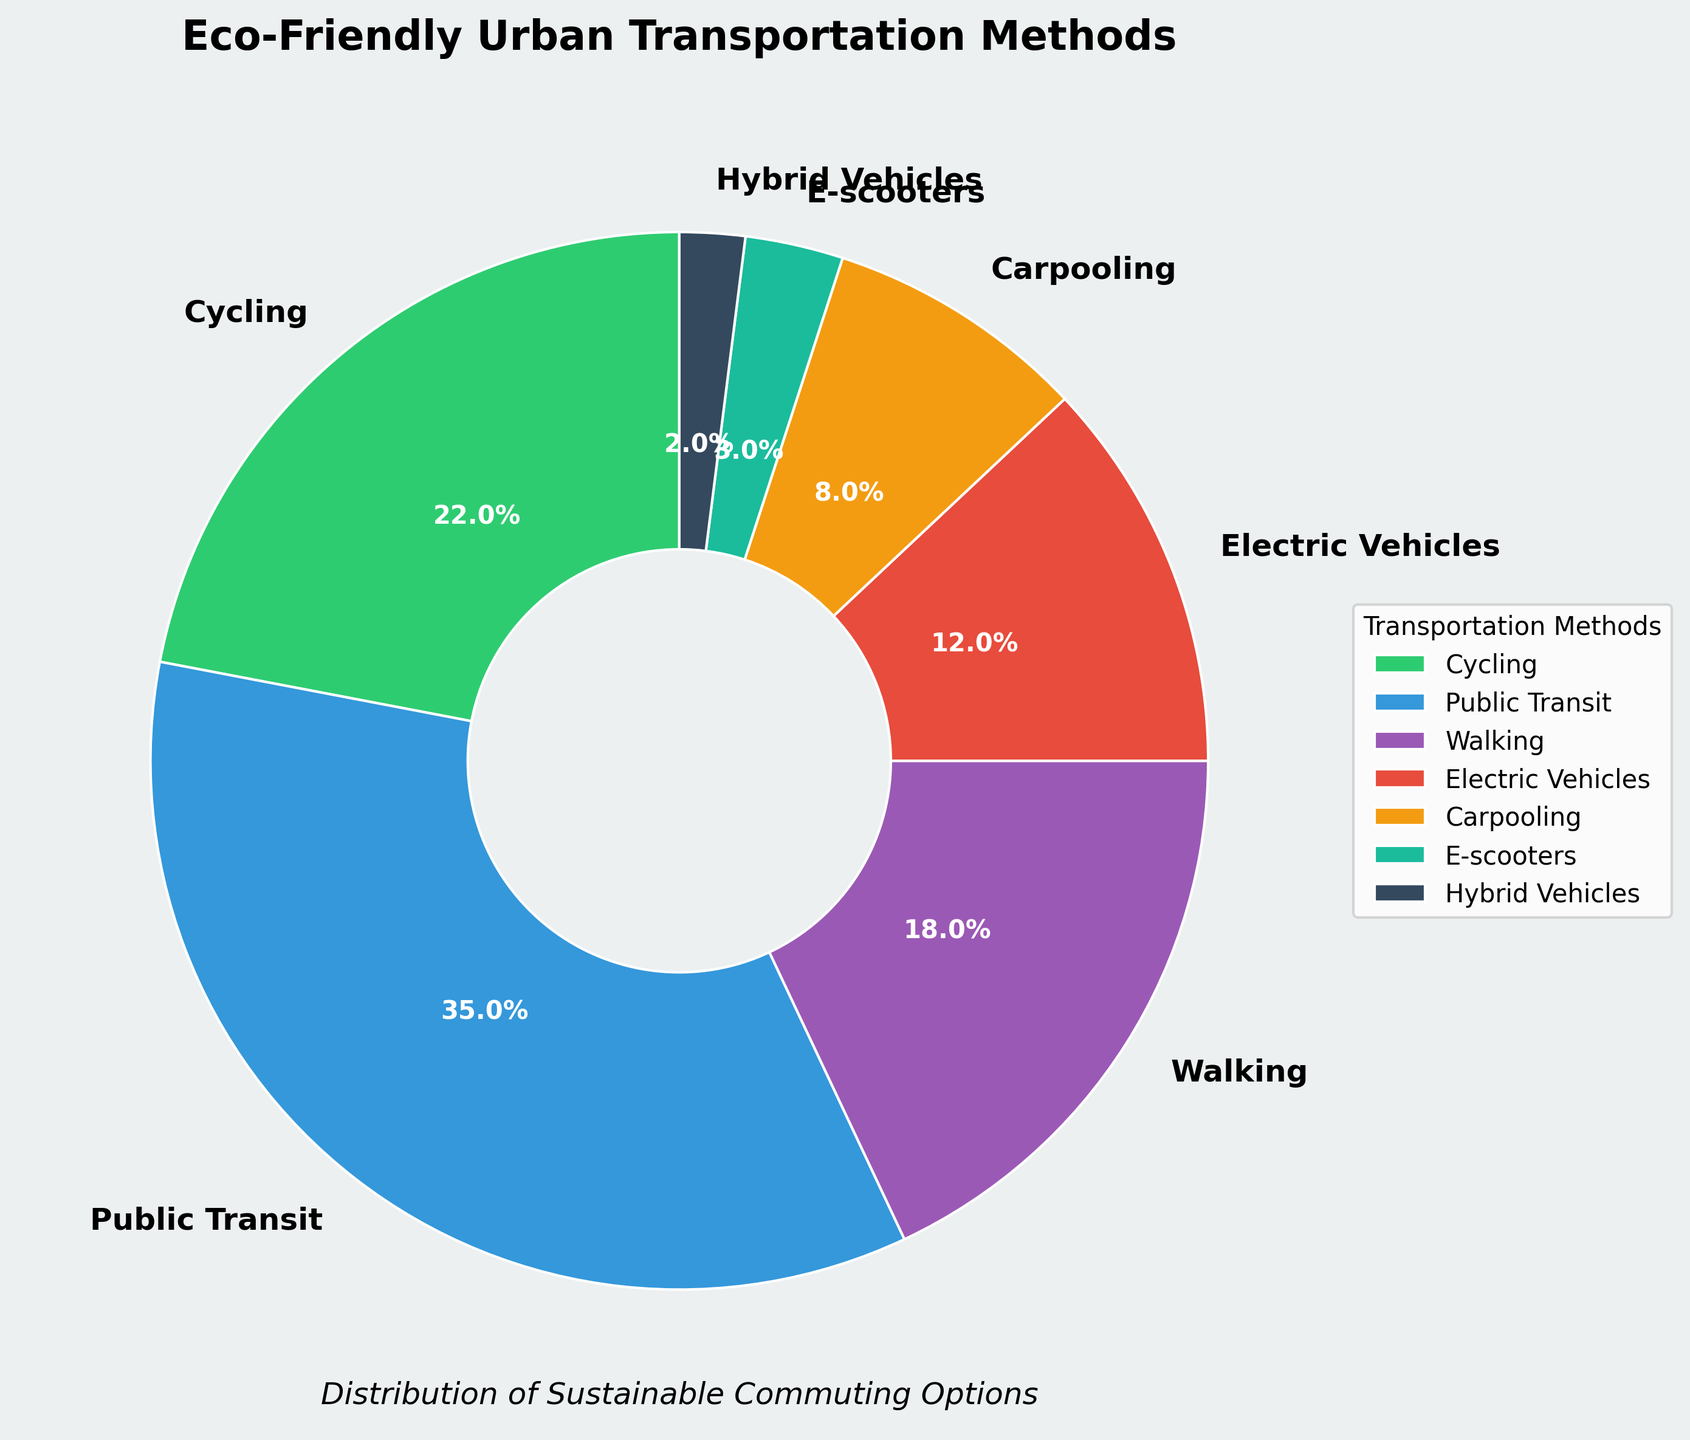What is the most popular eco-friendly transportation method among urban commuters? Looking at the pie chart, the slice with the largest percentage represents the most popular transportation method. "Public Transit" occupies the largest slice at 35%.
Answer: Public Transit Which three transportation methods together account for more than half of the eco-friendly commuting options? By examining the pie chart and summing the top percentages, we first take the three largest slices: Public Transit (35%), Cycling (22%), and Walking (18%). Adding these we get: 35% + 22% + 18% = 75%. 75% is more than half of the total distribution.
Answer: Public Transit, Cycling, Walking How much more popular is Walking compared to Electric Vehicles? According to the chart, Walking has 18% and Electric Vehicles have 12%. The difference can be calculated by subtracting the two percentages: 18% - 12% = 6%.
Answer: 6% What is the combined percentage for methods using vehicles (Electric Vehicles, Carpooling, and Hybrid Vehicles)? Summing up the individual slices of the vehicle methods we get: Electric Vehicles (12%) + Carpooling (8%) + Hybrid Vehicles (2%) = 22%.
Answer: 22% How does the share of Cycling compare to the combined share of Carpooling and E-scooters? From the pie chart, Cycling has a share of 22%. Carpooling has 8% and E-scooters have 3%. Adding Carpooling and E-scooters together we have: 8% + 3% = 11%, which is less than Cycling's 22%.
Answer: Cycling is more popular Which transportation method has the smallest share? The smallest slice on the pie chart represents the transportation method with the smallest share. Hybrid Vehicles have the smallest share at 2%.
Answer: Hybrid Vehicles How much more popular are Public Transit and Cycling combined compared to Walking and Electric Vehicles combined? First, sum the shares of Public Transit and Cycling: 35% + 22% = 57%. Then sum the shares of Walking and Electric Vehicles: 18% + 12% = 30%. The difference is 57% - 30% = 27%.
Answer: 27% What is the most popular non-vehicle based transportation method? Non-vehicle based methods in the chart are Cycling, Walking, and E-scooters. Among them, Cycling has the highest share at 22%.
Answer: Cycling List the transportation methods in descending order of popularity. By observing the sizes of the slices in the pie chart, we sort the methods from largest to smallest: Public Transit (35%), Cycling (22%), Walking (18%), Electric Vehicles (12%), Carpooling (8%), E-scooters (3%), Hybrid Vehicles (2%).
Answer: Public Transit, Cycling, Walking, Electric Vehicles, Carpooling, E-scooters, Hybrid Vehicles 